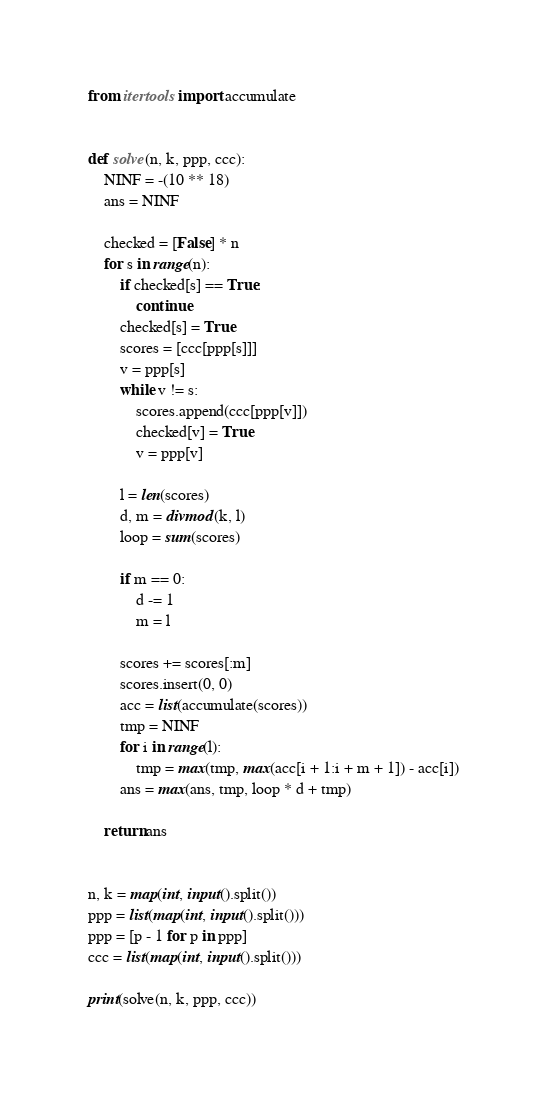<code> <loc_0><loc_0><loc_500><loc_500><_Python_>from itertools import accumulate


def solve(n, k, ppp, ccc):
    NINF = -(10 ** 18)
    ans = NINF

    checked = [False] * n
    for s in range(n):
        if checked[s] == True:
            continue
        checked[s] = True
        scores = [ccc[ppp[s]]]
        v = ppp[s]
        while v != s:
            scores.append(ccc[ppp[v]])
            checked[v] = True
            v = ppp[v]

        l = len(scores)
        d, m = divmod(k, l)
        loop = sum(scores)

        if m == 0:
            d -= 1
            m = l

        scores += scores[:m]
        scores.insert(0, 0)
        acc = list(accumulate(scores))
        tmp = NINF
        for i in range(l):
            tmp = max(tmp, max(acc[i + 1:i + m + 1]) - acc[i])
        ans = max(ans, tmp, loop * d + tmp)

    return ans


n, k = map(int, input().split())
ppp = list(map(int, input().split()))
ppp = [p - 1 for p in ppp]
ccc = list(map(int, input().split()))

print(solve(n, k, ppp, ccc))
</code> 